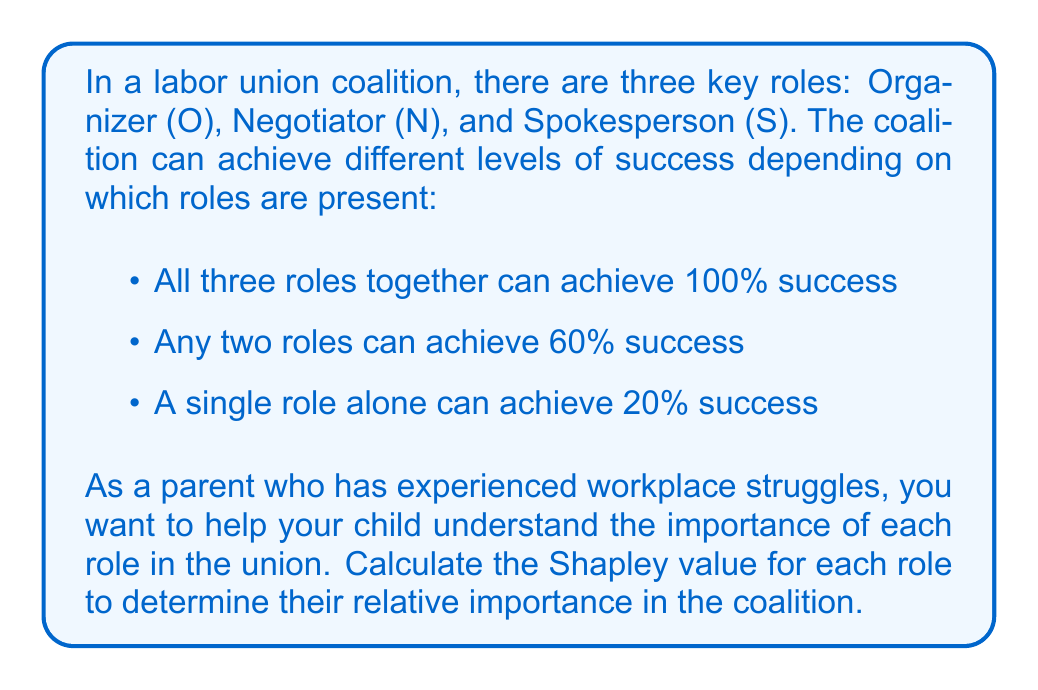Help me with this question. To calculate the Shapley value, we need to consider all possible orderings of the roles and determine the marginal contribution of each role in each ordering. There are 3! = 6 possible orderings.

Let's calculate the marginal contribution for each role in each ordering:

1. ONS: O(20), N(40), S(40)
2. OSN: O(20), S(40), N(40)
3. NOS: N(20), O(40), S(40)
4. NSO: N(20), S(40), O(40)
5. SON: S(20), O(40), N(40)
6. SNO: S(20), N(40), O(40)

Now, we sum up the marginal contributions for each role and divide by 6 (the total number of orderings):

Organizer (O):
$$ \text{Shapley Value}_O = \frac{20 + 20 + 40 + 40 + 40 + 40}{6} = \frac{200}{6} = \frac{100}{3} \approx 33.33 $$

Negotiator (N):
$$ \text{Shapley Value}_N = \frac{40 + 40 + 20 + 20 + 40 + 40}{6} = \frac{200}{6} = \frac{100}{3} \approx 33.33 $$

Spokesperson (S):
$$ \text{Shapley Value}_S = \frac{40 + 40 + 40 + 40 + 20 + 20}{6} = \frac{200}{6} = \frac{100}{3} \approx 33.33 $$

The Shapley value represents the average marginal contribution of each role to the coalition's success. In this case, all three roles have equal Shapley values, indicating that they are equally important to the coalition's success.
Answer: The Shapley values for each role in the labor union coalition are:

Organizer (O): $\frac{100}{3} \approx 33.33$
Negotiator (N): $\frac{100}{3} \approx 33.33$
Spokesperson (S): $\frac{100}{3} \approx 33.33$

All three roles have equal importance in the coalition. 